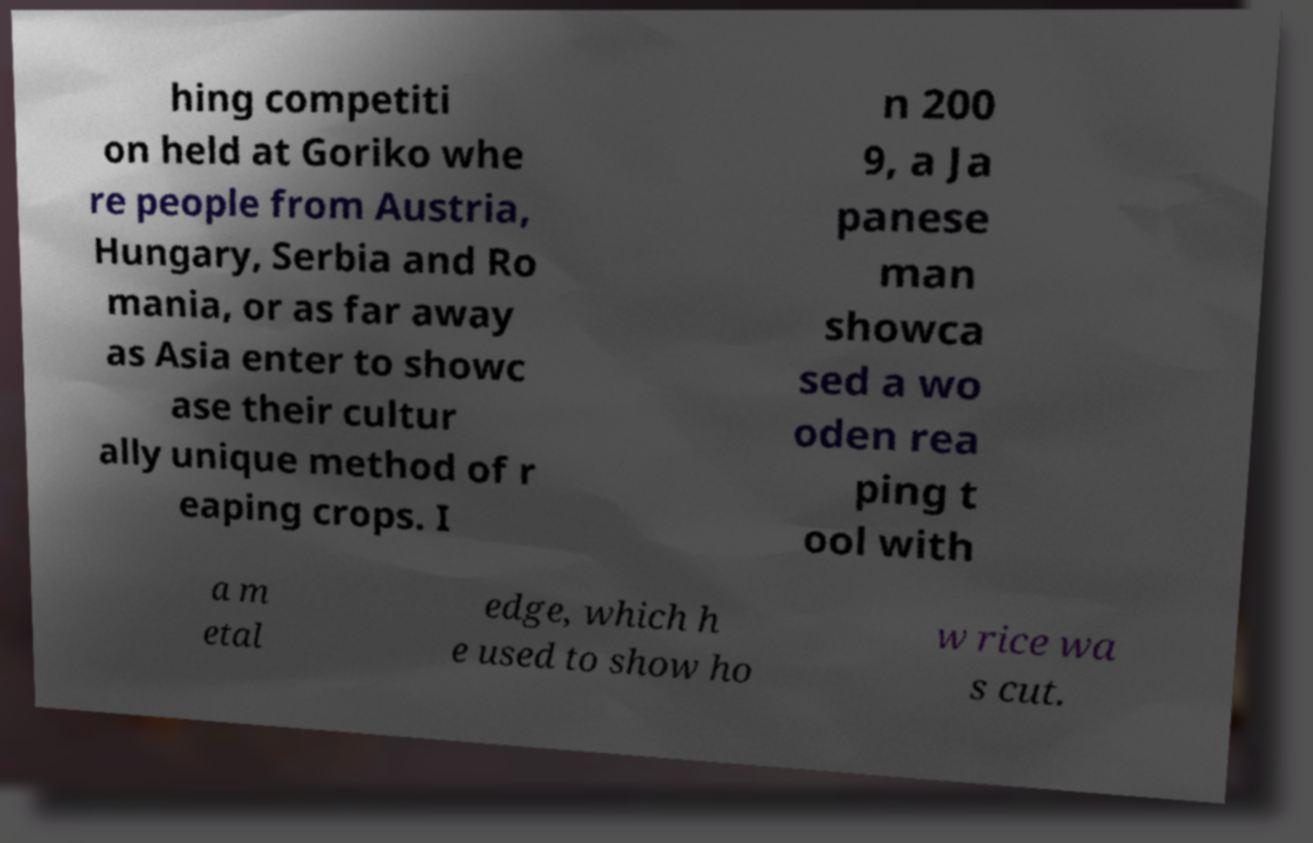For documentation purposes, I need the text within this image transcribed. Could you provide that? hing competiti on held at Goriko whe re people from Austria, Hungary, Serbia and Ro mania, or as far away as Asia enter to showc ase their cultur ally unique method of r eaping crops. I n 200 9, a Ja panese man showca sed a wo oden rea ping t ool with a m etal edge, which h e used to show ho w rice wa s cut. 